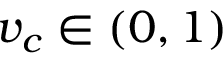Convert formula to latex. <formula><loc_0><loc_0><loc_500><loc_500>v _ { c } \in ( 0 , 1 )</formula> 